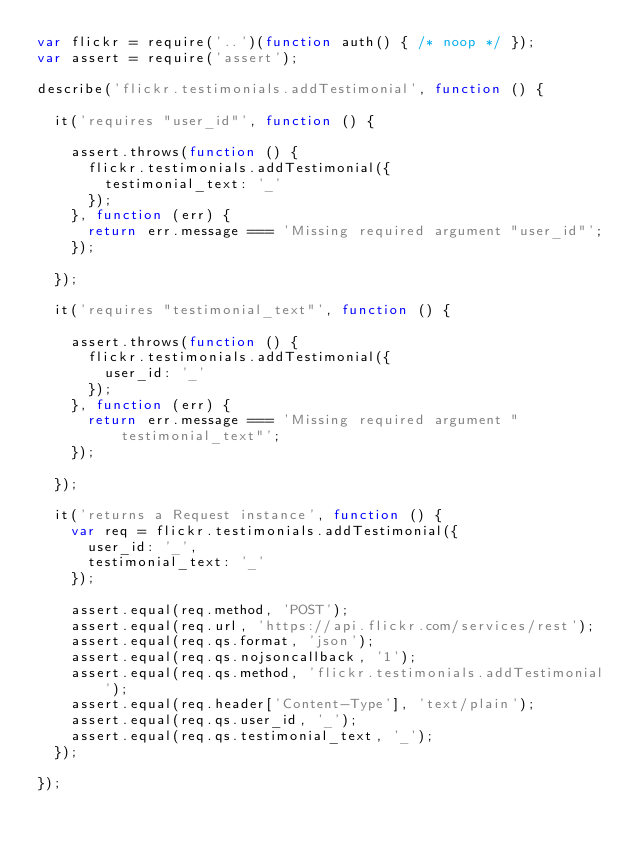Convert code to text. <code><loc_0><loc_0><loc_500><loc_500><_JavaScript_>var flickr = require('..')(function auth() { /* noop */ });
var assert = require('assert');

describe('flickr.testimonials.addTestimonial', function () {

	it('requires "user_id"', function () {

		assert.throws(function () {
			flickr.testimonials.addTestimonial({
				testimonial_text: '_'
			});
		}, function (err) {
			return err.message === 'Missing required argument "user_id"';
		});

	});

	it('requires "testimonial_text"', function () {

		assert.throws(function () {
			flickr.testimonials.addTestimonial({
				user_id: '_'
			});
		}, function (err) {
			return err.message === 'Missing required argument "testimonial_text"';
		});

	});

	it('returns a Request instance', function () {
		var req = flickr.testimonials.addTestimonial({
			user_id: '_',
			testimonial_text: '_'
		});

		assert.equal(req.method, 'POST');
		assert.equal(req.url, 'https://api.flickr.com/services/rest');
		assert.equal(req.qs.format, 'json');
		assert.equal(req.qs.nojsoncallback, '1');
		assert.equal(req.qs.method, 'flickr.testimonials.addTestimonial');
		assert.equal(req.header['Content-Type'], 'text/plain');
		assert.equal(req.qs.user_id, '_');
		assert.equal(req.qs.testimonial_text, '_');
	});

});
</code> 